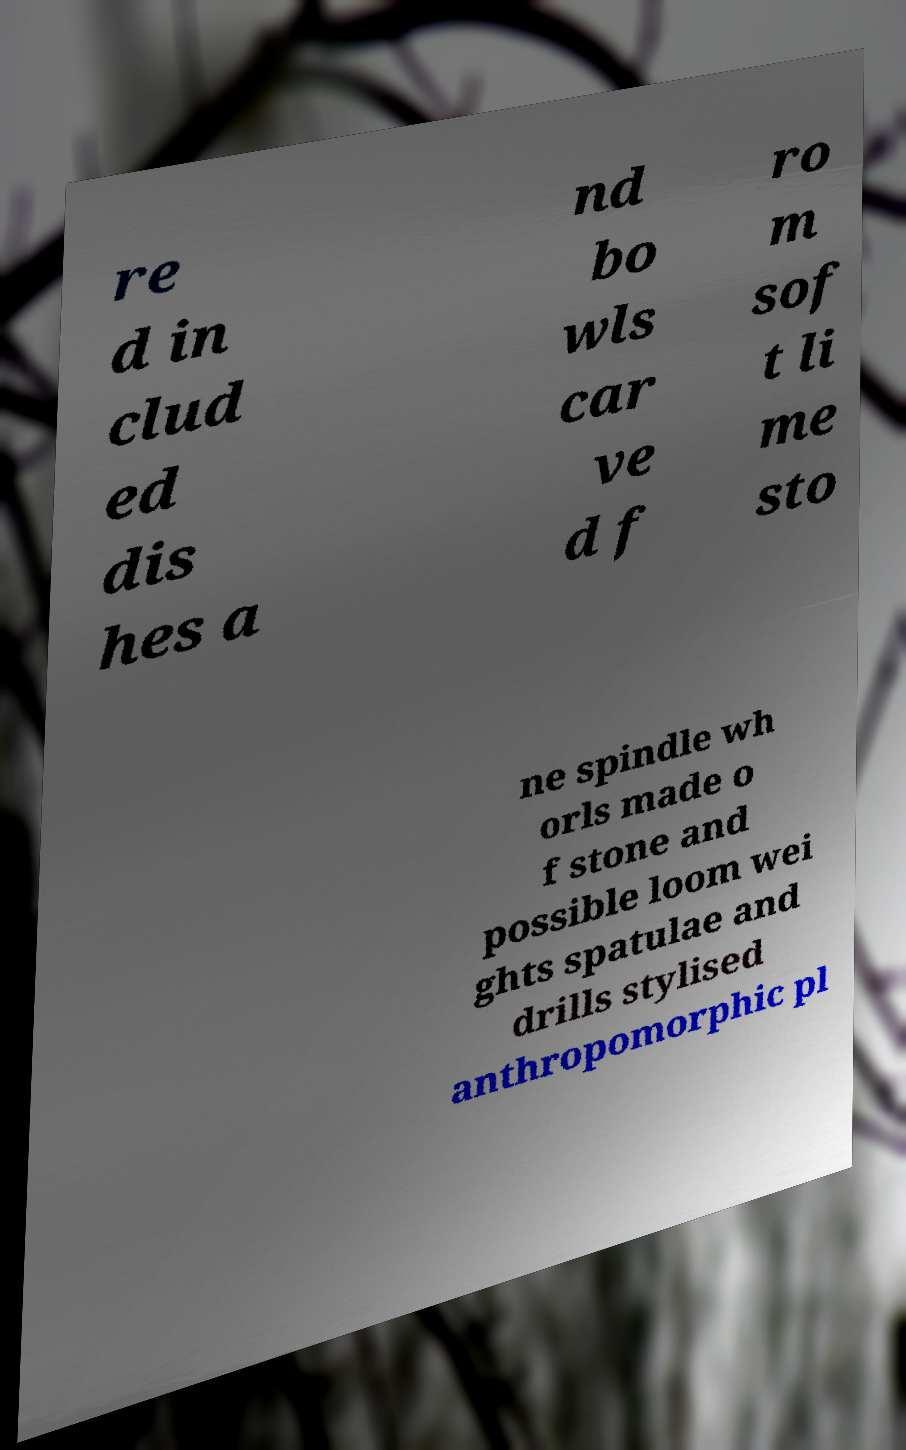I need the written content from this picture converted into text. Can you do that? re d in clud ed dis hes a nd bo wls car ve d f ro m sof t li me sto ne spindle wh orls made o f stone and possible loom wei ghts spatulae and drills stylised anthropomorphic pl 